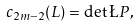Convert formula to latex. <formula><loc_0><loc_0><loc_500><loc_500>c _ { 2 m - 2 } ( L ) = \det \L P ,</formula> 